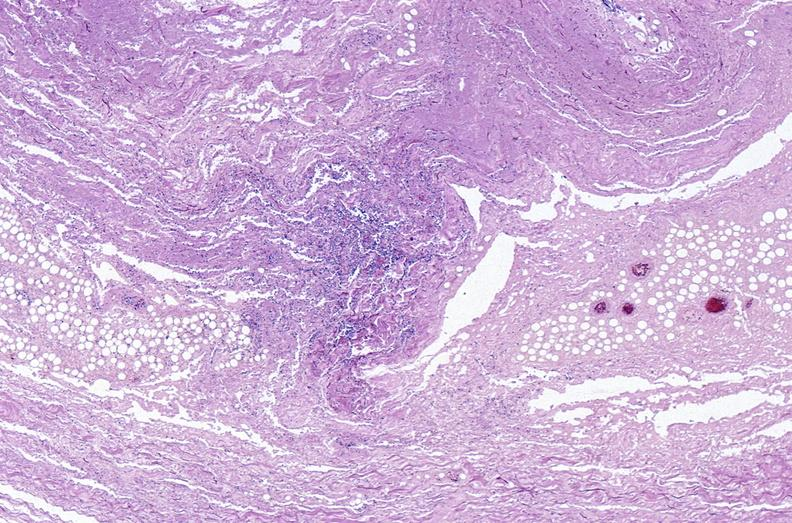does matting history of this case show panniculitis and fascitis?
Answer the question using a single word or phrase. No 